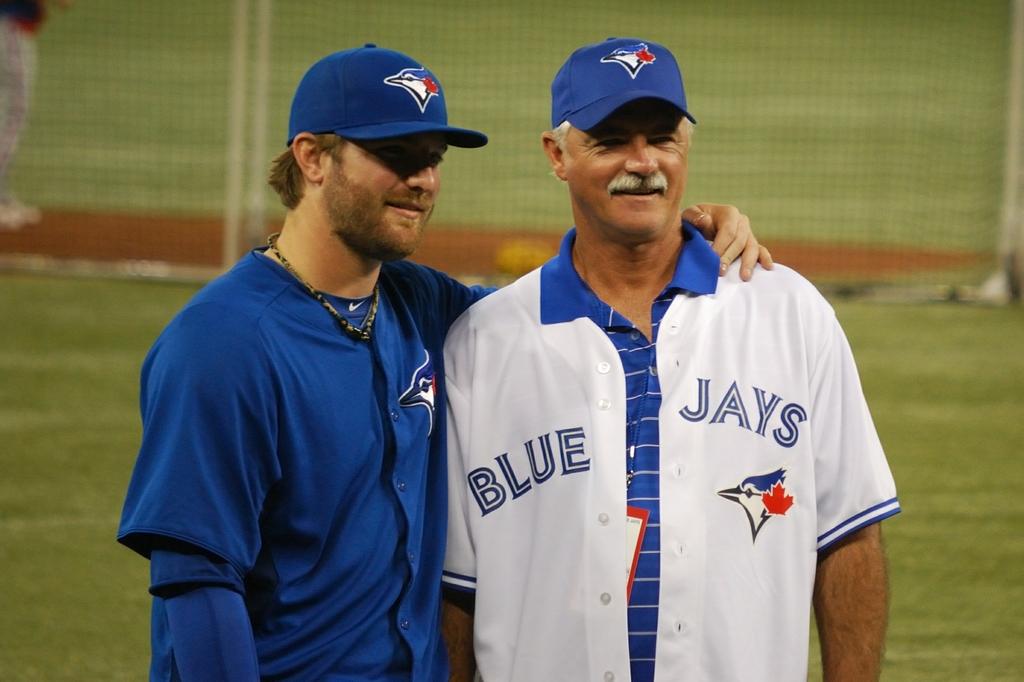Who does the player play for?
Your answer should be very brief. Blue jays. 